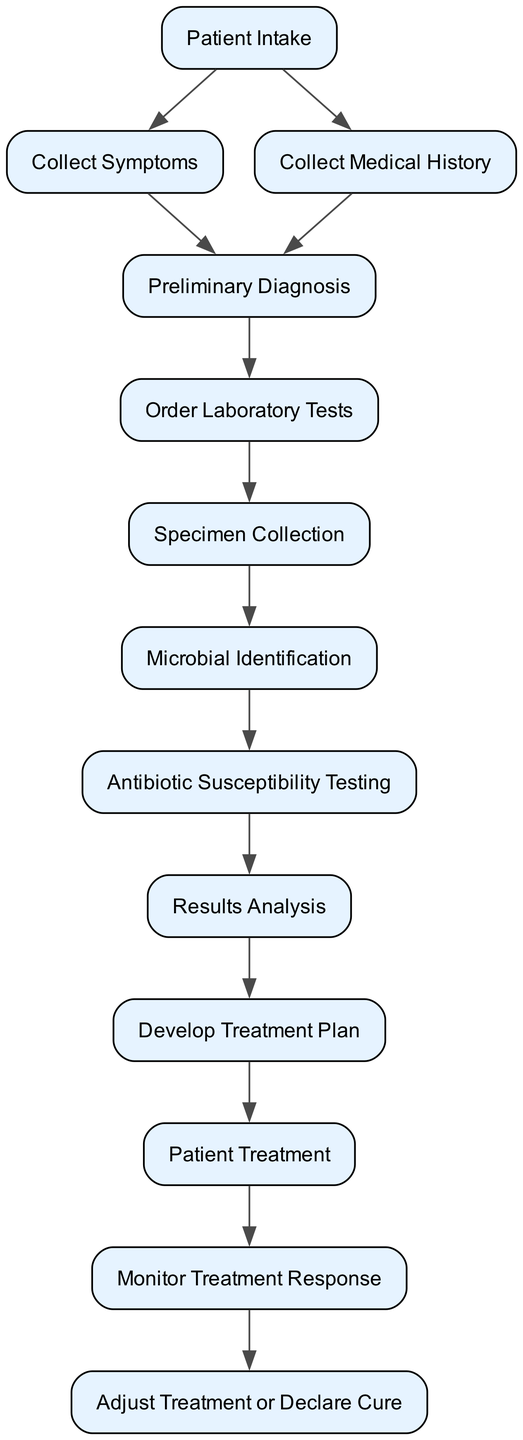What is the first step in the workflow? The first step listed in the diagram is "Patient Intake." This node has no inputs, indicating it is the starting point of the process.
Answer: Patient Intake How many nodes represent laboratory testing? The diagram includes two nodes related to laboratory testing: "Order Laboratory Tests" and "Antibiotic Susceptibility Testing." Each of these nodes is crucial for assessing the patient's infection and the appropriate antibiotics.
Answer: 2 What is the output of "Specimen Collection"? The output of "Specimen Collection" is "Microbial Identification." This indicates the process moves forward to identify the microorganism causing the infection after collecting the samples.
Answer: Microbial Identification Which node follows "Preliminary Diagnosis"? Following "Preliminary Diagnosis," the workflow continues to "Order Laboratory Tests." This shows that after forming an initial diagnosis, specific lab tests are ordered for further investigation.
Answer: Order Laboratory Tests What is the relationship between "Results Analysis" and "Develop Treatment Plan"? "Results Analysis" directly outputs to "Develop Treatment Plan," meaning that the analysis of lab results informs the creation of a tailored treatment plan for the patient.
Answer: Outputs to Explain the entire process from "Patient Intake" to "Adjust Treatment or Declare Cure." The process begins with "Patient Intake," where initial assessments are made. Next, "Collect Symptoms" and "Collect Medical History" occur, leading to "Preliminary Diagnosis." From there, lab tests are ordered, specimens collected, and microbial identification is performed. The identified microorganism undergoes susceptibility testing, and results are analyzed to develop a treatment plan. The selected treatment is then administered, and the patient's response is monitored, leading to either an adjustment of treatment or declaring a cure. This comprehensive flow illustrates all essential steps from intake to treatment conclusion.
Answer: Entire process What is the output of "Antibiotic Susceptibility Testing"? The output of "Antibiotic Susceptibility Testing" is "Results Analysis." This shows that the findings from the susceptibility tests are then interpreted to confirm the diagnosis.
Answer: Results Analysis 